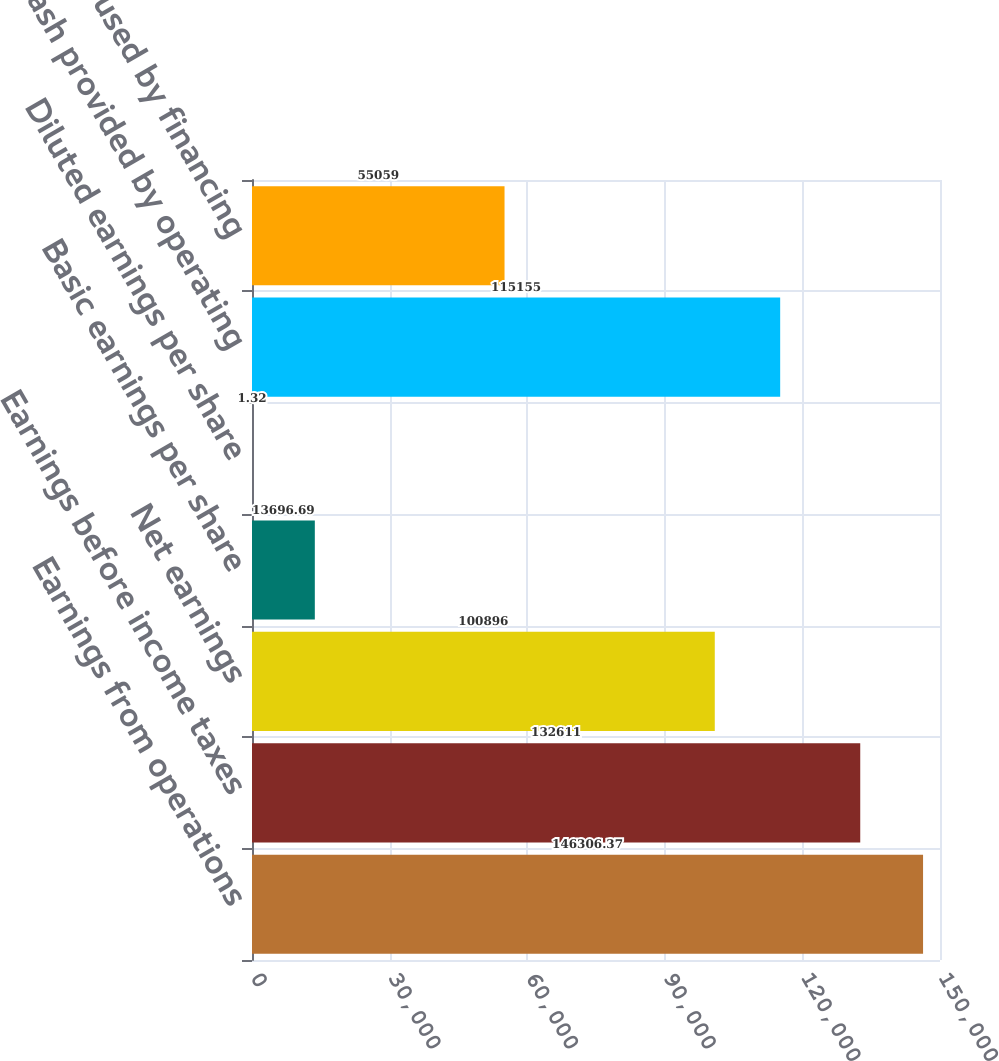<chart> <loc_0><loc_0><loc_500><loc_500><bar_chart><fcel>Earnings from operations<fcel>Earnings before income taxes<fcel>Net earnings<fcel>Basic earnings per share<fcel>Diluted earnings per share<fcel>Net cash provided by operating<fcel>Net cash used by financing<nl><fcel>146306<fcel>132611<fcel>100896<fcel>13696.7<fcel>1.32<fcel>115155<fcel>55059<nl></chart> 